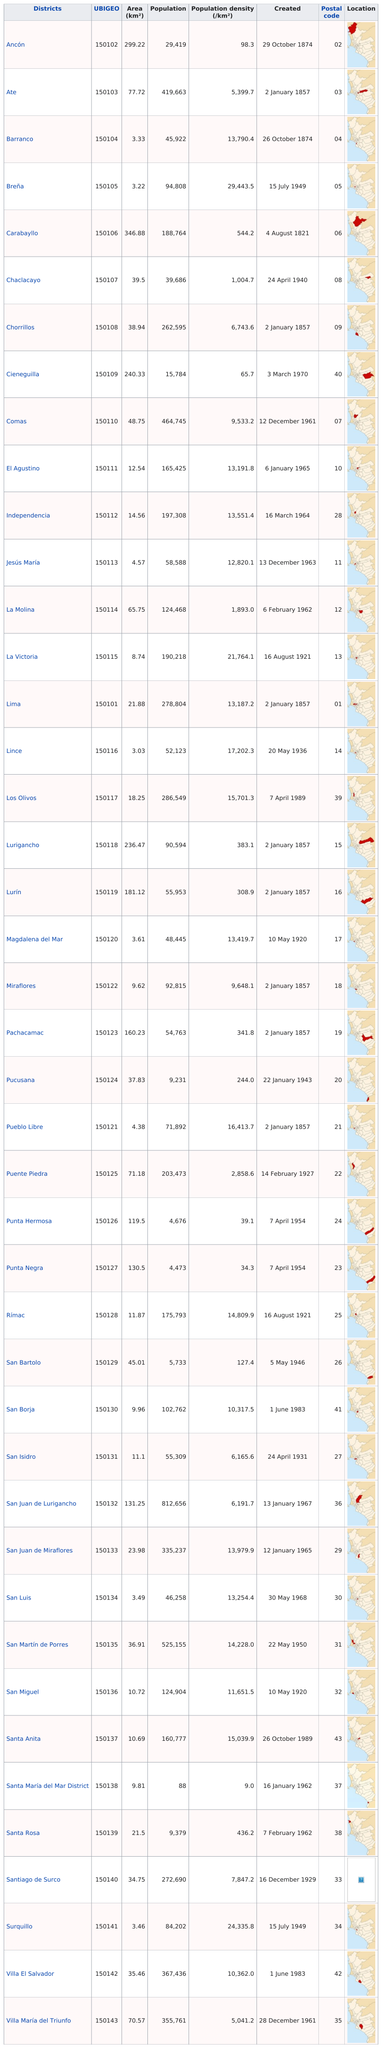Point out several critical features in this image. Santa María del Mar District has the least amount of population among all the districts. Carabayllo was the first district to be created. Out of the total number of districts, 31 have a population density of at least 1000.0. There are 43 districts in this city. The district with the greatest population in this city is San Juan de Lurigancho. 